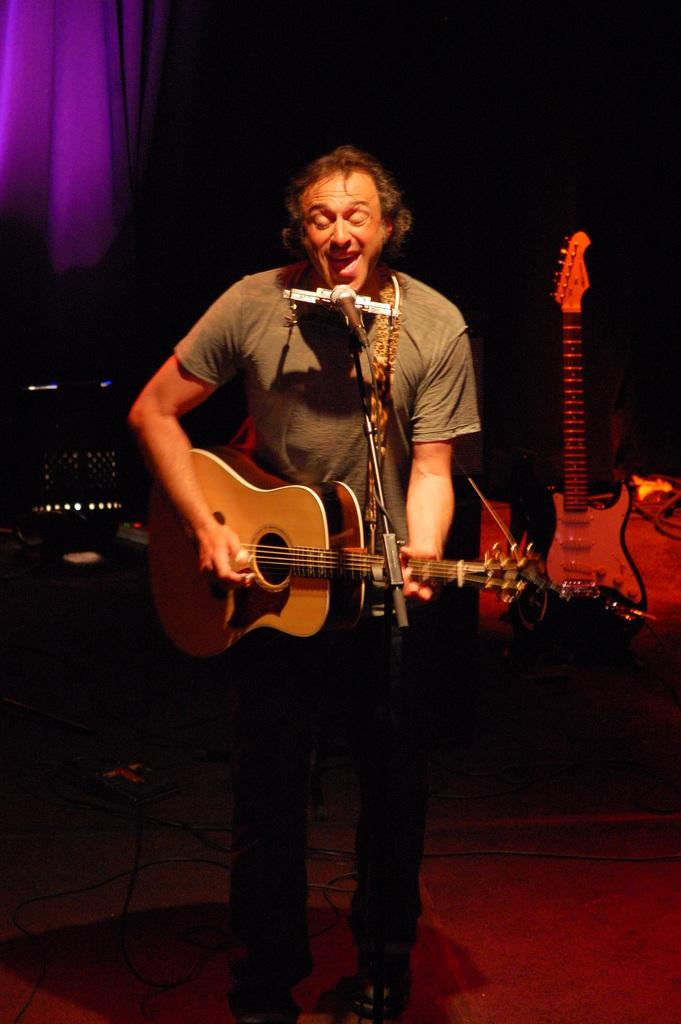Who is the main subject in the image? There is a man in the image. What is the man doing in the image? The man is standing in front of a microphone and playing a guitar. What can be seen beneath the man's feet in the image? There is a floor visible in the image. What is present in the background of the image? There is a cloth in the background of the image. What type of cake is being served to the men in the image? There is no cake or men present in the image; it features a man playing a guitar in front of a microphone. What color is the yarn used to knit the scarf in the image? There is no yarn or scarf present in the image. 